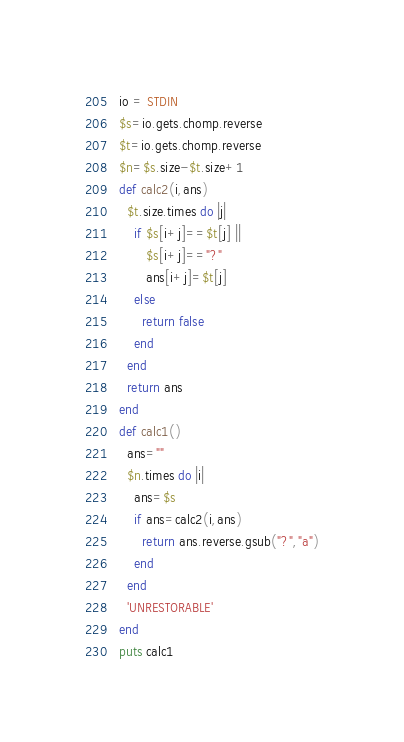Convert code to text. <code><loc_0><loc_0><loc_500><loc_500><_Ruby_>io = STDIN
$s=io.gets.chomp.reverse
$t=io.gets.chomp.reverse
$n=$s.size-$t.size+1
def calc2(i,ans)
  $t.size.times do |j|
    if $s[i+j]==$t[j] ||
       $s[i+j]=="?"
       ans[i+j]=$t[j]
    else
      return false
    end
  end
  return ans
end
def calc1()
  ans=""
  $n.times do |i|
    ans=$s
    if ans=calc2(i,ans)
      return ans.reverse.gsub("?","a")
    end
  end
  'UNRESTORABLE'
end
puts calc1
</code> 